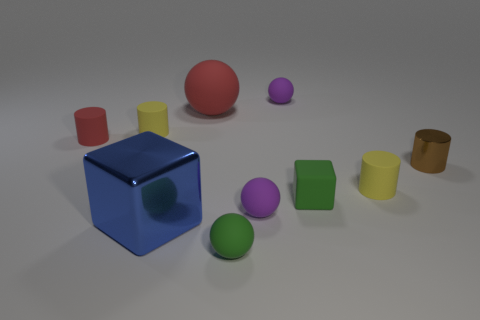Is the material of the tiny green sphere the same as the tiny yellow object to the right of the blue metallic cube?
Your response must be concise. Yes. There is a small green rubber object behind the green rubber thing left of the tiny green cube; what is its shape?
Give a very brief answer. Cube. There is a matte cylinder that is in front of the brown metallic cylinder; does it have the same size as the tiny red matte cylinder?
Make the answer very short. Yes. What number of other objects are the same shape as the large blue shiny object?
Offer a very short reply. 1. There is a small matte cylinder in front of the tiny red cylinder; is its color the same as the large matte sphere?
Keep it short and to the point. No. Are there any small matte cylinders of the same color as the rubber cube?
Offer a very short reply. No. There is a large red sphere; what number of green matte spheres are behind it?
Keep it short and to the point. 0. How many other things are there of the same size as the blue thing?
Ensure brevity in your answer.  1. Is the purple sphere that is behind the small brown metal thing made of the same material as the small yellow cylinder that is on the left side of the big red ball?
Provide a short and direct response. Yes. The matte cube that is the same size as the brown metallic object is what color?
Your response must be concise. Green. 